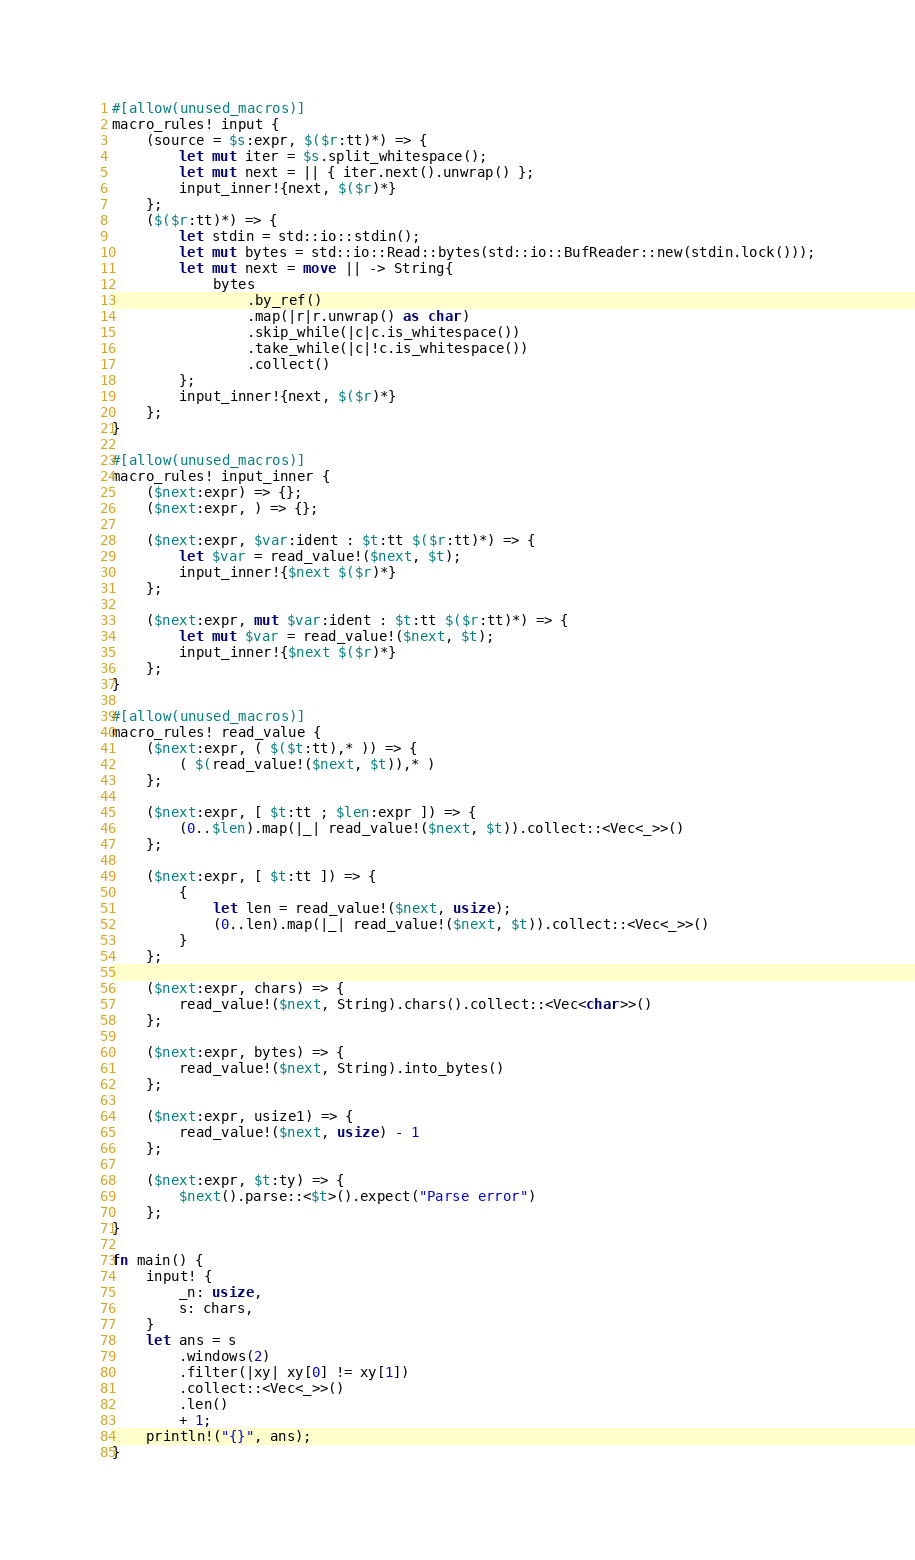Convert code to text. <code><loc_0><loc_0><loc_500><loc_500><_Rust_>#[allow(unused_macros)]
macro_rules! input {
    (source = $s:expr, $($r:tt)*) => {
        let mut iter = $s.split_whitespace();
        let mut next = || { iter.next().unwrap() };
        input_inner!{next, $($r)*}
    };
    ($($r:tt)*) => {
        let stdin = std::io::stdin();
        let mut bytes = std::io::Read::bytes(std::io::BufReader::new(stdin.lock()));
        let mut next = move || -> String{
            bytes
                .by_ref()
                .map(|r|r.unwrap() as char)
                .skip_while(|c|c.is_whitespace())
                .take_while(|c|!c.is_whitespace())
                .collect()
        };
        input_inner!{next, $($r)*}
    };
}

#[allow(unused_macros)]
macro_rules! input_inner {
    ($next:expr) => {};
    ($next:expr, ) => {};

    ($next:expr, $var:ident : $t:tt $($r:tt)*) => {
        let $var = read_value!($next, $t);
        input_inner!{$next $($r)*}
    };

    ($next:expr, mut $var:ident : $t:tt $($r:tt)*) => {
        let mut $var = read_value!($next, $t);
        input_inner!{$next $($r)*}
    };
}

#[allow(unused_macros)]
macro_rules! read_value {
    ($next:expr, ( $($t:tt),* )) => {
        ( $(read_value!($next, $t)),* )
    };

    ($next:expr, [ $t:tt ; $len:expr ]) => {
        (0..$len).map(|_| read_value!($next, $t)).collect::<Vec<_>>()
    };

    ($next:expr, [ $t:tt ]) => {
        {
            let len = read_value!($next, usize);
            (0..len).map(|_| read_value!($next, $t)).collect::<Vec<_>>()
        }
    };

    ($next:expr, chars) => {
        read_value!($next, String).chars().collect::<Vec<char>>()
    };

    ($next:expr, bytes) => {
        read_value!($next, String).into_bytes()
    };

    ($next:expr, usize1) => {
        read_value!($next, usize) - 1
    };

    ($next:expr, $t:ty) => {
        $next().parse::<$t>().expect("Parse error")
    };
}

fn main() {
    input! {
        _n: usize,
        s: chars,
    }
    let ans = s
        .windows(2)
        .filter(|xy| xy[0] != xy[1])
        .collect::<Vec<_>>()
        .len()
        + 1;
    println!("{}", ans);
}
</code> 